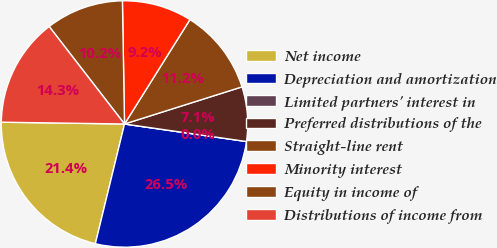<chart> <loc_0><loc_0><loc_500><loc_500><pie_chart><fcel>Net income<fcel>Depreciation and amortization<fcel>Limited partners' interest in<fcel>Preferred distributions of the<fcel>Straight-line rent<fcel>Minority interest<fcel>Equity in income of<fcel>Distributions of income from<nl><fcel>21.43%<fcel>26.53%<fcel>0.0%<fcel>7.14%<fcel>11.22%<fcel>9.18%<fcel>10.2%<fcel>14.29%<nl></chart> 